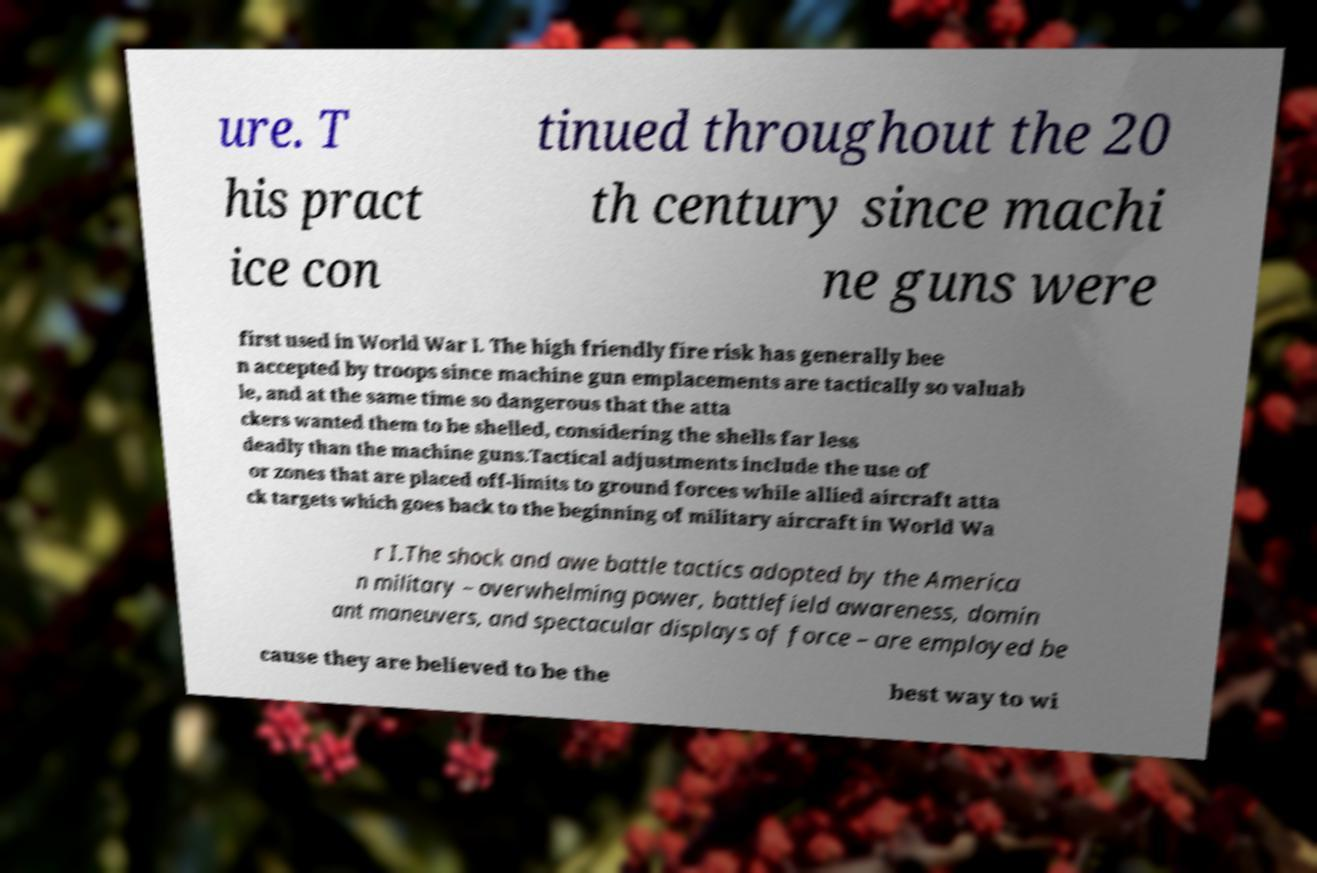Can you accurately transcribe the text from the provided image for me? ure. T his pract ice con tinued throughout the 20 th century since machi ne guns were first used in World War I. The high friendly fire risk has generally bee n accepted by troops since machine gun emplacements are tactically so valuab le, and at the same time so dangerous that the atta ckers wanted them to be shelled, considering the shells far less deadly than the machine guns.Tactical adjustments include the use of or zones that are placed off-limits to ground forces while allied aircraft atta ck targets which goes back to the beginning of military aircraft in World Wa r I.The shock and awe battle tactics adopted by the America n military – overwhelming power, battlefield awareness, domin ant maneuvers, and spectacular displays of force – are employed be cause they are believed to be the best way to wi 